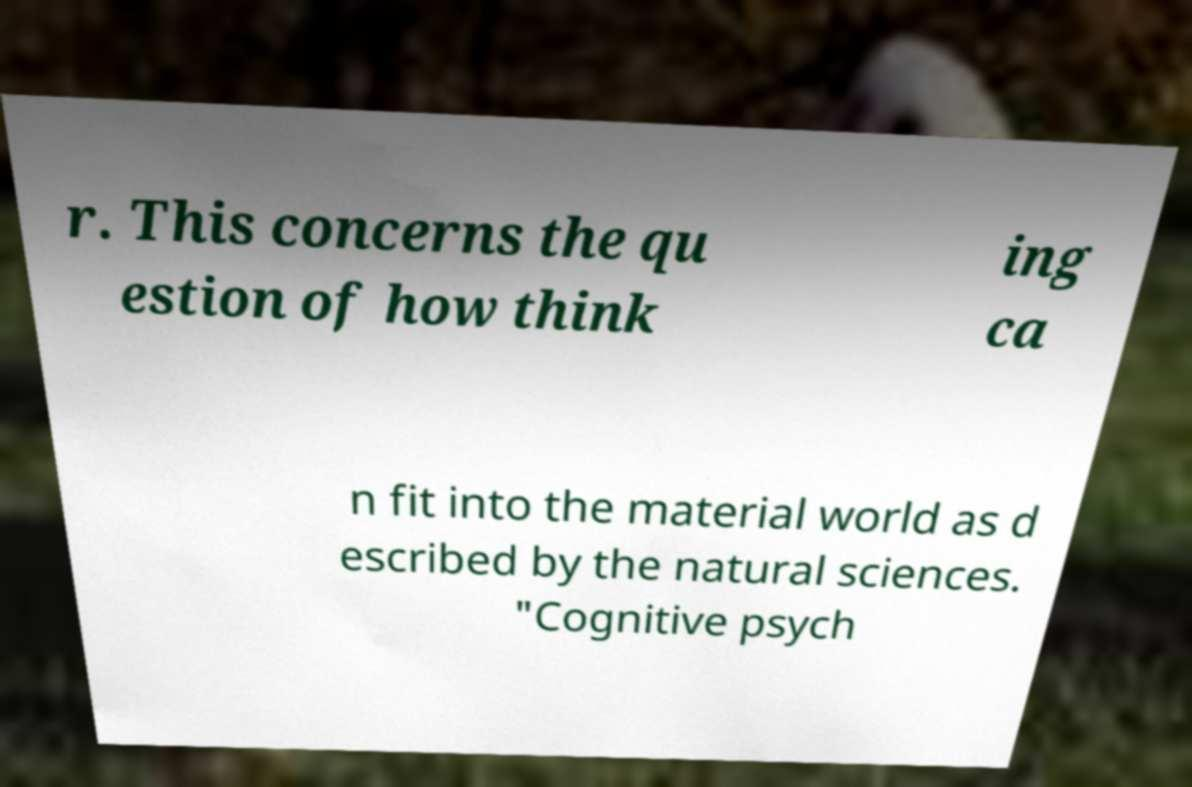There's text embedded in this image that I need extracted. Can you transcribe it verbatim? r. This concerns the qu estion of how think ing ca n fit into the material world as d escribed by the natural sciences. "Cognitive psych 